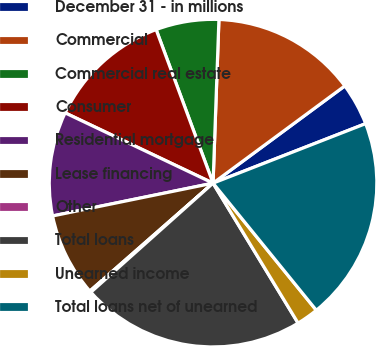<chart> <loc_0><loc_0><loc_500><loc_500><pie_chart><fcel>December 31 - in millions<fcel>Commercial<fcel>Commercial real estate<fcel>Consumer<fcel>Residential mortgage<fcel>Lease financing<fcel>Other<fcel>Total loans<fcel>Unearned income<fcel>Total loans net of unearned<nl><fcel>4.2%<fcel>14.31%<fcel>6.22%<fcel>12.29%<fcel>10.27%<fcel>8.24%<fcel>0.15%<fcel>22.09%<fcel>2.17%<fcel>20.06%<nl></chart> 